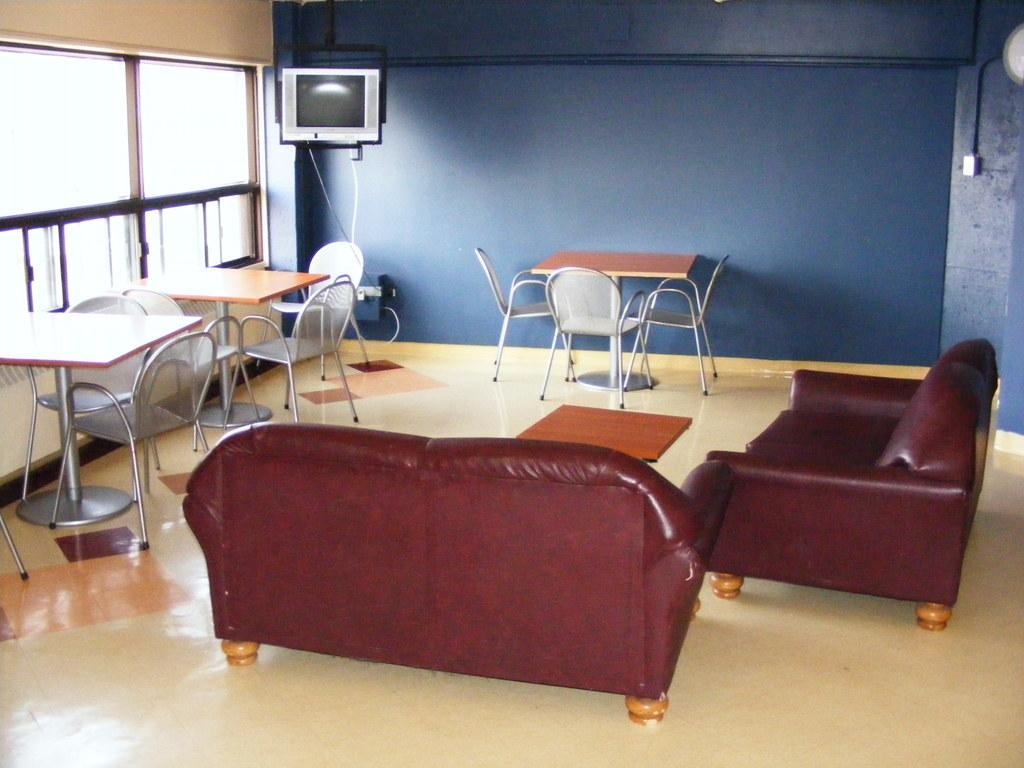What color are the couches in the room? The couches in the room are red. What type of furniture is present in the room besides couches? There are tables and chairs in the room. Where is the television located in the room? The television is on top of something, likely a table or stand. What color are the walls of the room? The walls of the room are in blue color. What advice is given by the person sitting on the red couch in the image? There is no person or conversation depicted in the image, so no advice can be given. Can you see a kiss between two people in the image? There is no kiss or any indication of a romantic interaction between people in the image. 